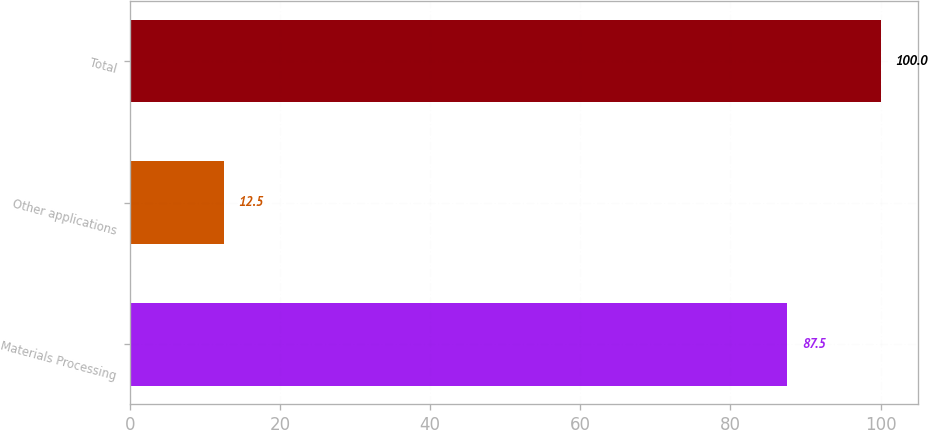Convert chart. <chart><loc_0><loc_0><loc_500><loc_500><bar_chart><fcel>Materials Processing<fcel>Other applications<fcel>Total<nl><fcel>87.5<fcel>12.5<fcel>100<nl></chart> 